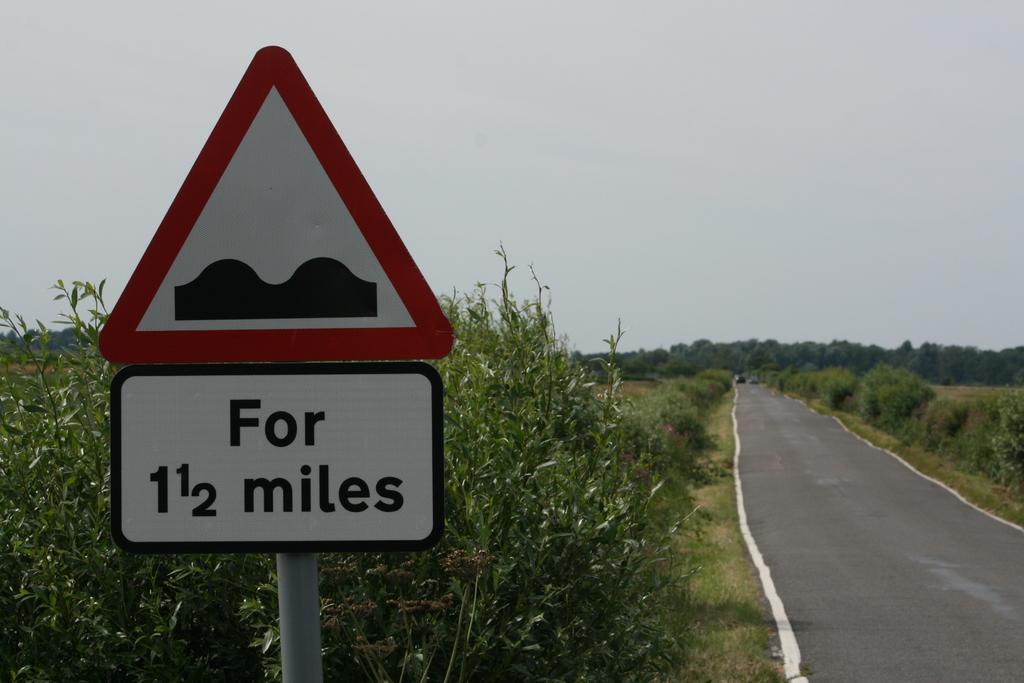How long will there be speed bumps?
Your answer should be very brief. 1 1/2 miles. 